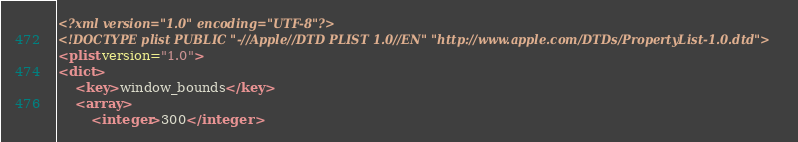<code> <loc_0><loc_0><loc_500><loc_500><_XML_><?xml version="1.0" encoding="UTF-8"?>
<!DOCTYPE plist PUBLIC "-//Apple//DTD PLIST 1.0//EN" "http://www.apple.com/DTDs/PropertyList-1.0.dtd">
<plist version="1.0">
<dict>
	<key>window_bounds</key>
	<array>
		<integer>300</integer></code> 